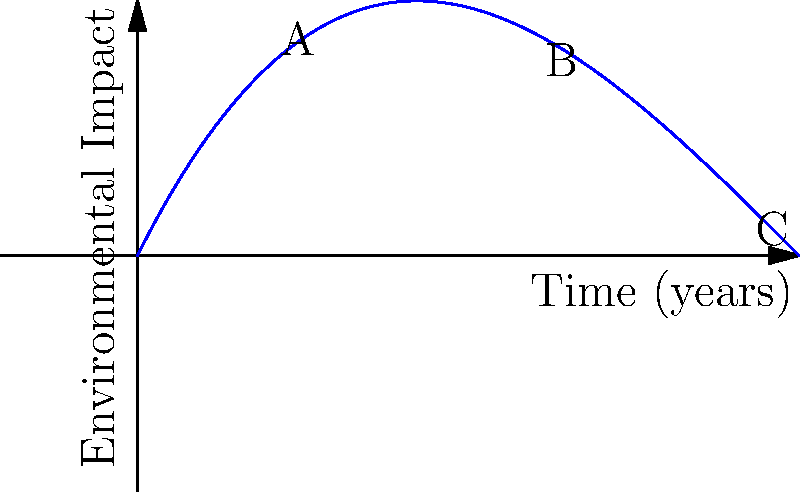As a screenplay writer focusing on social issues, you're researching the environmental impact of industrialization for your next script. The graph shows a polynomial model of environmental impact over time. If this curve represents the progression of a small town's industrialization, at which point (A, B, or C) would you set your story to highlight the most dramatic change in environmental conditions, and why? To determine the most dramatic change in environmental conditions, we need to analyze the behavior of the polynomial curve at points A, B, and C:

1. Point A (around 2 years):
   The curve is rising steadily, indicating the beginning of environmental impact.

2. Point B (around 6 years):
   The curve reaches its minimum point and starts to rise again. This represents a turning point in the environmental impact.

3. Point C (around 10 years):
   The curve is rising rapidly, showing a significant increase in environmental impact.

To find the most dramatic change, we need to consider the rate of change (slope) at each point:

- At A: The slope is positive but decreasing.
- At B: The slope is approximately zero (turning point).
- At C: The slope is positive and increasing rapidly.

The most dramatic change occurs where the rate of change is highest, which is at point C. This rapid increase in environmental impact would provide the most compelling backdrop for a story highlighting the consequences of unchecked industrialization.
Answer: Point C 